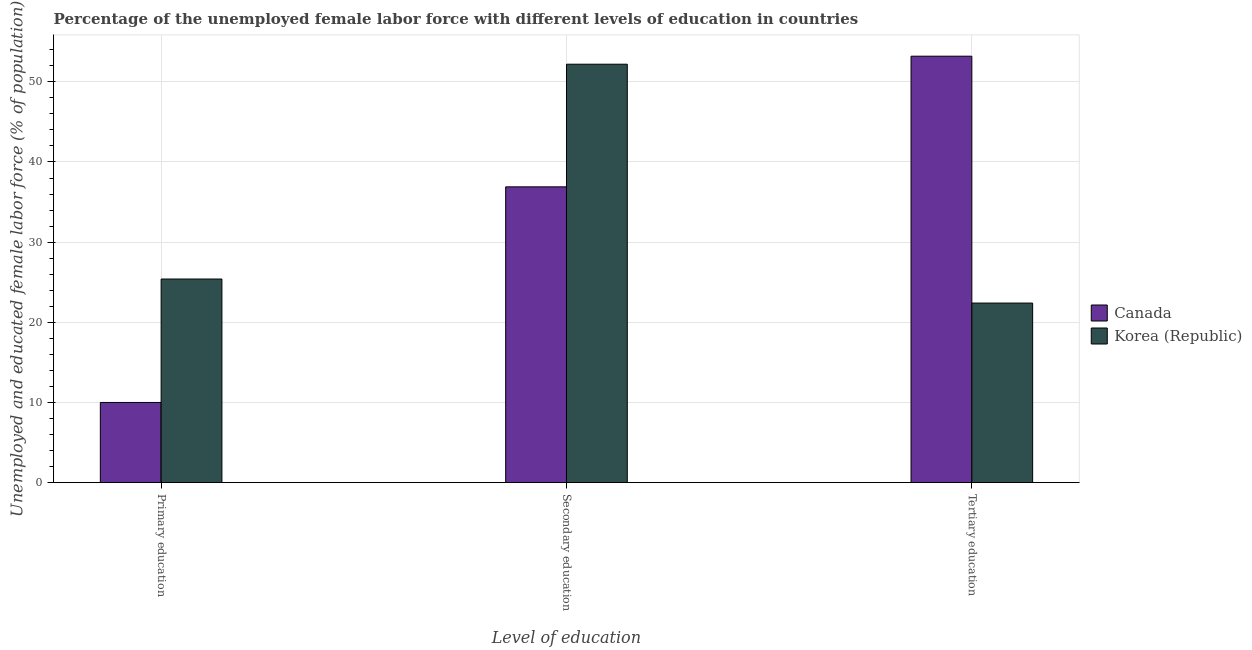How many different coloured bars are there?
Your answer should be compact. 2. How many bars are there on the 2nd tick from the left?
Make the answer very short. 2. What is the label of the 1st group of bars from the left?
Offer a very short reply. Primary education. What is the percentage of female labor force who received primary education in Canada?
Provide a short and direct response. 10. Across all countries, what is the maximum percentage of female labor force who received primary education?
Provide a succinct answer. 25.4. Across all countries, what is the minimum percentage of female labor force who received primary education?
Your answer should be very brief. 10. In which country was the percentage of female labor force who received secondary education maximum?
Provide a succinct answer. Korea (Republic). What is the total percentage of female labor force who received secondary education in the graph?
Your answer should be very brief. 89.1. What is the difference between the percentage of female labor force who received tertiary education in Canada and that in Korea (Republic)?
Offer a very short reply. 30.8. What is the difference between the percentage of female labor force who received secondary education in Canada and the percentage of female labor force who received primary education in Korea (Republic)?
Give a very brief answer. 11.5. What is the average percentage of female labor force who received primary education per country?
Your answer should be very brief. 17.7. What is the difference between the percentage of female labor force who received tertiary education and percentage of female labor force who received primary education in Canada?
Your response must be concise. 43.2. What is the ratio of the percentage of female labor force who received primary education in Korea (Republic) to that in Canada?
Make the answer very short. 2.54. Is the difference between the percentage of female labor force who received secondary education in Canada and Korea (Republic) greater than the difference between the percentage of female labor force who received primary education in Canada and Korea (Republic)?
Give a very brief answer. Yes. What is the difference between the highest and the second highest percentage of female labor force who received tertiary education?
Offer a terse response. 30.8. What is the difference between the highest and the lowest percentage of female labor force who received primary education?
Give a very brief answer. 15.4. Is the sum of the percentage of female labor force who received secondary education in Korea (Republic) and Canada greater than the maximum percentage of female labor force who received tertiary education across all countries?
Give a very brief answer. Yes. What does the 2nd bar from the left in Tertiary education represents?
Make the answer very short. Korea (Republic). Are all the bars in the graph horizontal?
Provide a succinct answer. No. What is the difference between two consecutive major ticks on the Y-axis?
Provide a succinct answer. 10. Are the values on the major ticks of Y-axis written in scientific E-notation?
Your response must be concise. No. How are the legend labels stacked?
Provide a short and direct response. Vertical. What is the title of the graph?
Offer a very short reply. Percentage of the unemployed female labor force with different levels of education in countries. Does "Portugal" appear as one of the legend labels in the graph?
Your answer should be very brief. No. What is the label or title of the X-axis?
Ensure brevity in your answer.  Level of education. What is the label or title of the Y-axis?
Your answer should be compact. Unemployed and educated female labor force (% of population). What is the Unemployed and educated female labor force (% of population) of Canada in Primary education?
Offer a very short reply. 10. What is the Unemployed and educated female labor force (% of population) in Korea (Republic) in Primary education?
Offer a terse response. 25.4. What is the Unemployed and educated female labor force (% of population) of Canada in Secondary education?
Provide a succinct answer. 36.9. What is the Unemployed and educated female labor force (% of population) in Korea (Republic) in Secondary education?
Make the answer very short. 52.2. What is the Unemployed and educated female labor force (% of population) of Canada in Tertiary education?
Provide a succinct answer. 53.2. What is the Unemployed and educated female labor force (% of population) in Korea (Republic) in Tertiary education?
Ensure brevity in your answer.  22.4. Across all Level of education, what is the maximum Unemployed and educated female labor force (% of population) in Canada?
Provide a succinct answer. 53.2. Across all Level of education, what is the maximum Unemployed and educated female labor force (% of population) in Korea (Republic)?
Keep it short and to the point. 52.2. Across all Level of education, what is the minimum Unemployed and educated female labor force (% of population) in Canada?
Keep it short and to the point. 10. Across all Level of education, what is the minimum Unemployed and educated female labor force (% of population) in Korea (Republic)?
Provide a succinct answer. 22.4. What is the total Unemployed and educated female labor force (% of population) in Canada in the graph?
Provide a succinct answer. 100.1. What is the total Unemployed and educated female labor force (% of population) of Korea (Republic) in the graph?
Make the answer very short. 100. What is the difference between the Unemployed and educated female labor force (% of population) in Canada in Primary education and that in Secondary education?
Provide a succinct answer. -26.9. What is the difference between the Unemployed and educated female labor force (% of population) of Korea (Republic) in Primary education and that in Secondary education?
Keep it short and to the point. -26.8. What is the difference between the Unemployed and educated female labor force (% of population) of Canada in Primary education and that in Tertiary education?
Your answer should be compact. -43.2. What is the difference between the Unemployed and educated female labor force (% of population) of Korea (Republic) in Primary education and that in Tertiary education?
Ensure brevity in your answer.  3. What is the difference between the Unemployed and educated female labor force (% of population) of Canada in Secondary education and that in Tertiary education?
Provide a short and direct response. -16.3. What is the difference between the Unemployed and educated female labor force (% of population) of Korea (Republic) in Secondary education and that in Tertiary education?
Your response must be concise. 29.8. What is the difference between the Unemployed and educated female labor force (% of population) of Canada in Primary education and the Unemployed and educated female labor force (% of population) of Korea (Republic) in Secondary education?
Offer a very short reply. -42.2. What is the difference between the Unemployed and educated female labor force (% of population) in Canada in Primary education and the Unemployed and educated female labor force (% of population) in Korea (Republic) in Tertiary education?
Keep it short and to the point. -12.4. What is the average Unemployed and educated female labor force (% of population) of Canada per Level of education?
Your answer should be very brief. 33.37. What is the average Unemployed and educated female labor force (% of population) of Korea (Republic) per Level of education?
Your answer should be very brief. 33.33. What is the difference between the Unemployed and educated female labor force (% of population) of Canada and Unemployed and educated female labor force (% of population) of Korea (Republic) in Primary education?
Offer a terse response. -15.4. What is the difference between the Unemployed and educated female labor force (% of population) in Canada and Unemployed and educated female labor force (% of population) in Korea (Republic) in Secondary education?
Provide a succinct answer. -15.3. What is the difference between the Unemployed and educated female labor force (% of population) in Canada and Unemployed and educated female labor force (% of population) in Korea (Republic) in Tertiary education?
Offer a very short reply. 30.8. What is the ratio of the Unemployed and educated female labor force (% of population) of Canada in Primary education to that in Secondary education?
Keep it short and to the point. 0.27. What is the ratio of the Unemployed and educated female labor force (% of population) in Korea (Republic) in Primary education to that in Secondary education?
Keep it short and to the point. 0.49. What is the ratio of the Unemployed and educated female labor force (% of population) in Canada in Primary education to that in Tertiary education?
Keep it short and to the point. 0.19. What is the ratio of the Unemployed and educated female labor force (% of population) of Korea (Republic) in Primary education to that in Tertiary education?
Give a very brief answer. 1.13. What is the ratio of the Unemployed and educated female labor force (% of population) in Canada in Secondary education to that in Tertiary education?
Ensure brevity in your answer.  0.69. What is the ratio of the Unemployed and educated female labor force (% of population) in Korea (Republic) in Secondary education to that in Tertiary education?
Your answer should be compact. 2.33. What is the difference between the highest and the second highest Unemployed and educated female labor force (% of population) in Canada?
Your response must be concise. 16.3. What is the difference between the highest and the second highest Unemployed and educated female labor force (% of population) in Korea (Republic)?
Keep it short and to the point. 26.8. What is the difference between the highest and the lowest Unemployed and educated female labor force (% of population) in Canada?
Your answer should be very brief. 43.2. What is the difference between the highest and the lowest Unemployed and educated female labor force (% of population) in Korea (Republic)?
Offer a terse response. 29.8. 